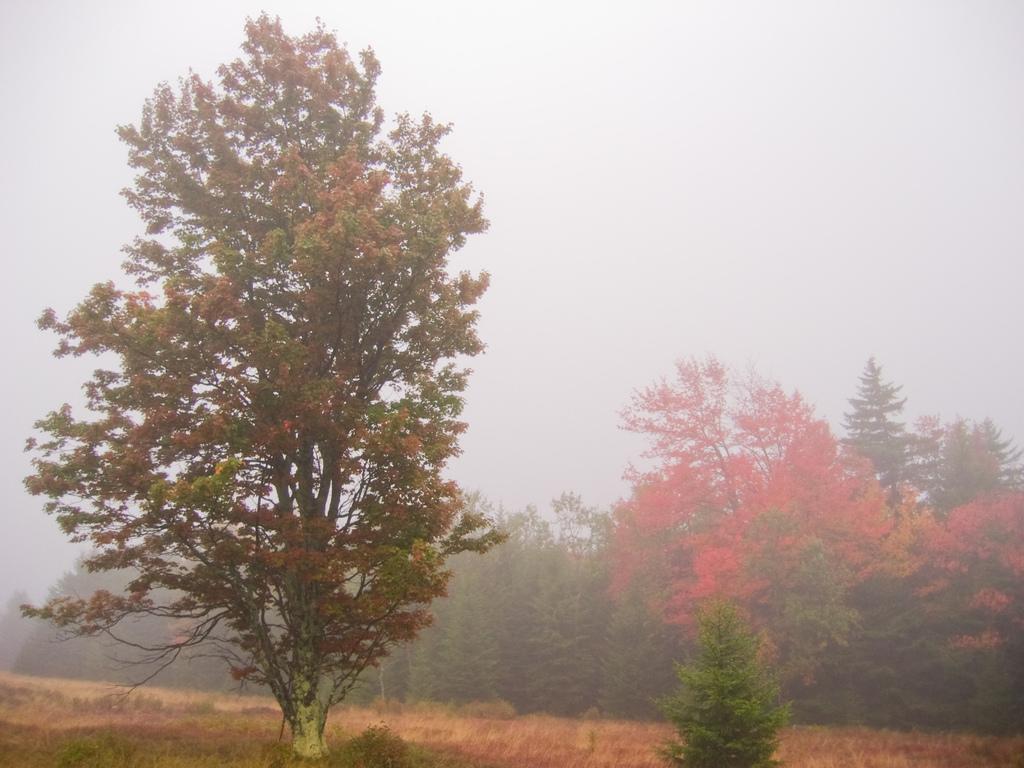How would you summarize this image in a sentence or two? In this picture there are trees and there are orange color flowers on the trees. At the top there is sky. At the bottom there is grass. 